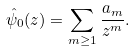<formula> <loc_0><loc_0><loc_500><loc_500>\hat { \psi } _ { 0 } ( z ) = \sum _ { m \geq 1 } \frac { a _ { m } } { z ^ { m } } .</formula> 